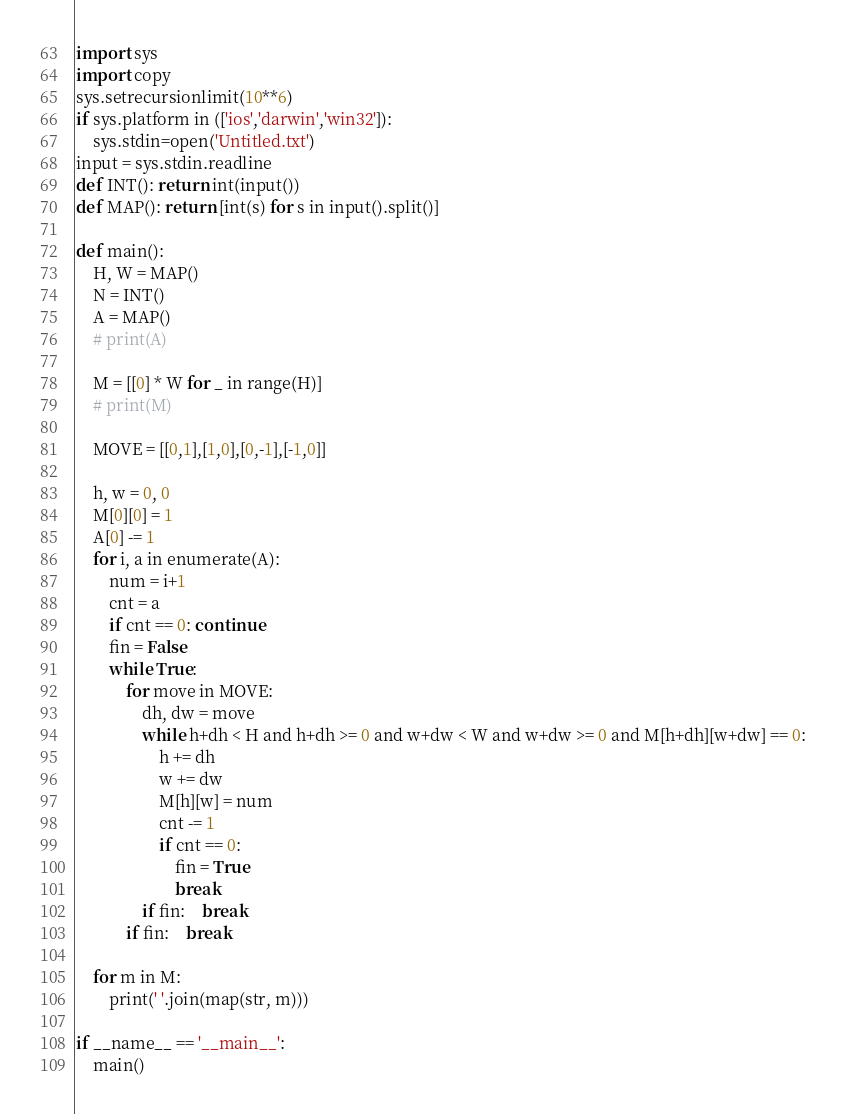<code> <loc_0><loc_0><loc_500><loc_500><_Python_>import sys
import copy
sys.setrecursionlimit(10**6)
if sys.platform in (['ios','darwin','win32']):
	sys.stdin=open('Untitled.txt')
input = sys.stdin.readline
def INT(): return int(input())
def MAP(): return [int(s) for s in input().split()]

def main():
	H, W = MAP()
	N = INT()
	A = MAP()
	# print(A)
	
	M = [[0] * W for _ in range(H)]
	# print(M)

	MOVE = [[0,1],[1,0],[0,-1],[-1,0]]

	h, w = 0, 0
	M[0][0] = 1
	A[0] -= 1
	for i, a in enumerate(A):
		num = i+1
		cnt = a
		if cnt == 0: continue
		fin = False
		while True:
			for move in MOVE:
				dh, dw = move
				while h+dh < H and h+dh >= 0 and w+dw < W and w+dw >= 0 and M[h+dh][w+dw] == 0:
					h += dh
					w += dw
					M[h][w] = num
					cnt -= 1
					if cnt == 0:
						fin = True
						break
				if fin:	break
			if fin:	break

	for m in M:
		print(' '.join(map(str, m)))

if __name__ == '__main__':
	main()
</code> 